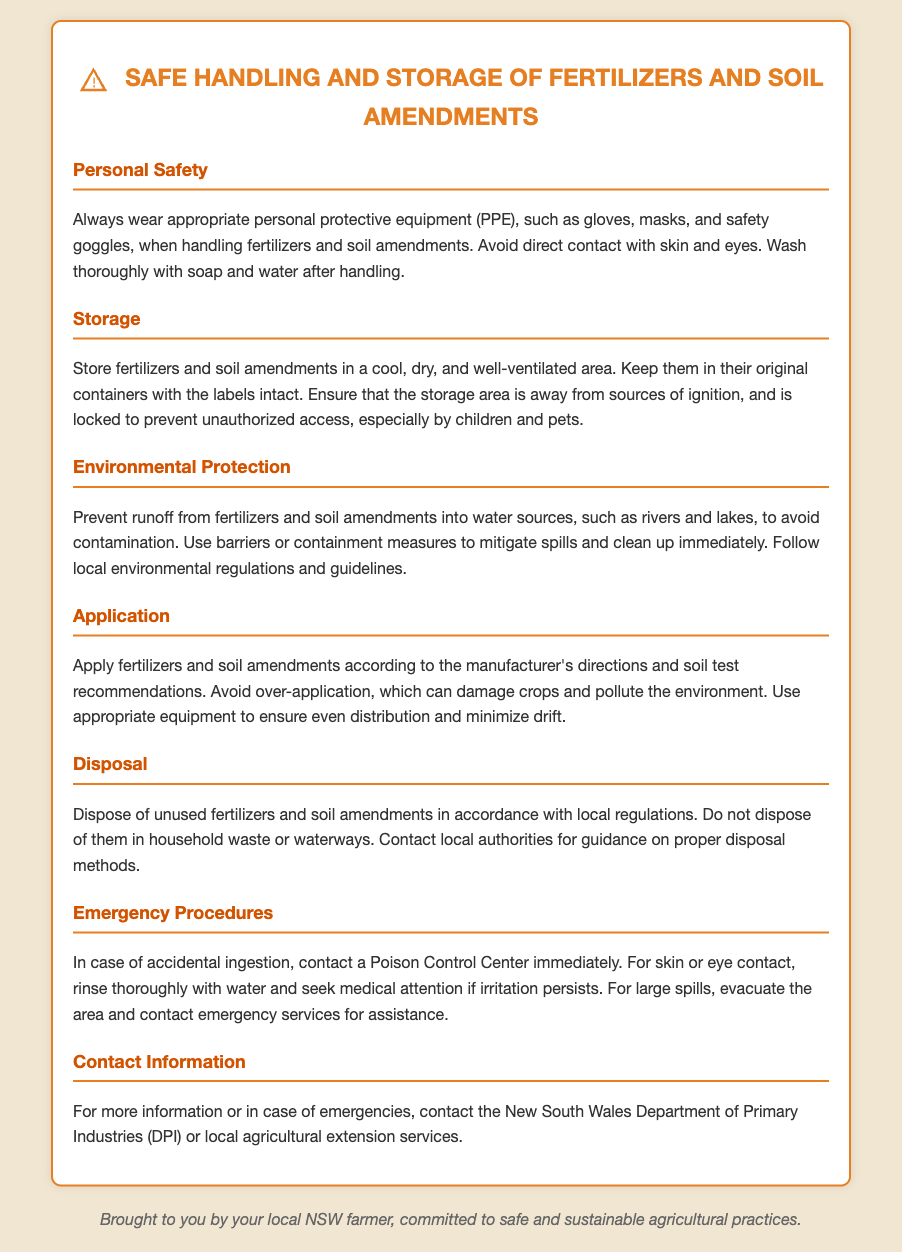what personal protective equipment should be worn? The document states to wear gloves, masks, and safety goggles when handling fertilizers and soil amendments.
Answer: gloves, masks, safety goggles how should fertilizers be stored? Fertilizers should be stored in a cool, dry, and well-ventilated area, in their original containers with the labels intact.
Answer: cool, dry, well-ventilated what should be done in case of accidental ingestion? In case of accidental ingestion, the document advises to contact a Poison Control Center immediately.
Answer: contact Poison Control Center what measures should be taken to prevent contamination of water sources? The document emphasizes preventing runoff from fertilizers and soil amendments into water sources to avoid contamination.
Answer: prevent runoff what is the main purpose of the document? The document serves as a warning label regarding safe handling and storage of fertilizers and soil amendments.
Answer: safe handling and storage who should be contacted for more information or emergencies? The document mentions contacting the New South Wales Department of Primary Industries (DPI) or local agricultural extension services for more information.
Answer: New South Wales Department of Primary Industries (DPI) what should you do in case of skin or eye contact? For skin or eye contact, the document instructs to rinse thoroughly with water and seek medical attention if irritation persists.
Answer: rinse thoroughly with water what happens if fertilizers are over-applied? Over-application of fertilizers can damage crops and pollute the environment according to the document.
Answer: damage crops, pollute environment where should fertilizers be protected from? Fertilizers should be kept away from sources of ignition according to the storage guidelines in the document.
Answer: sources of ignition 